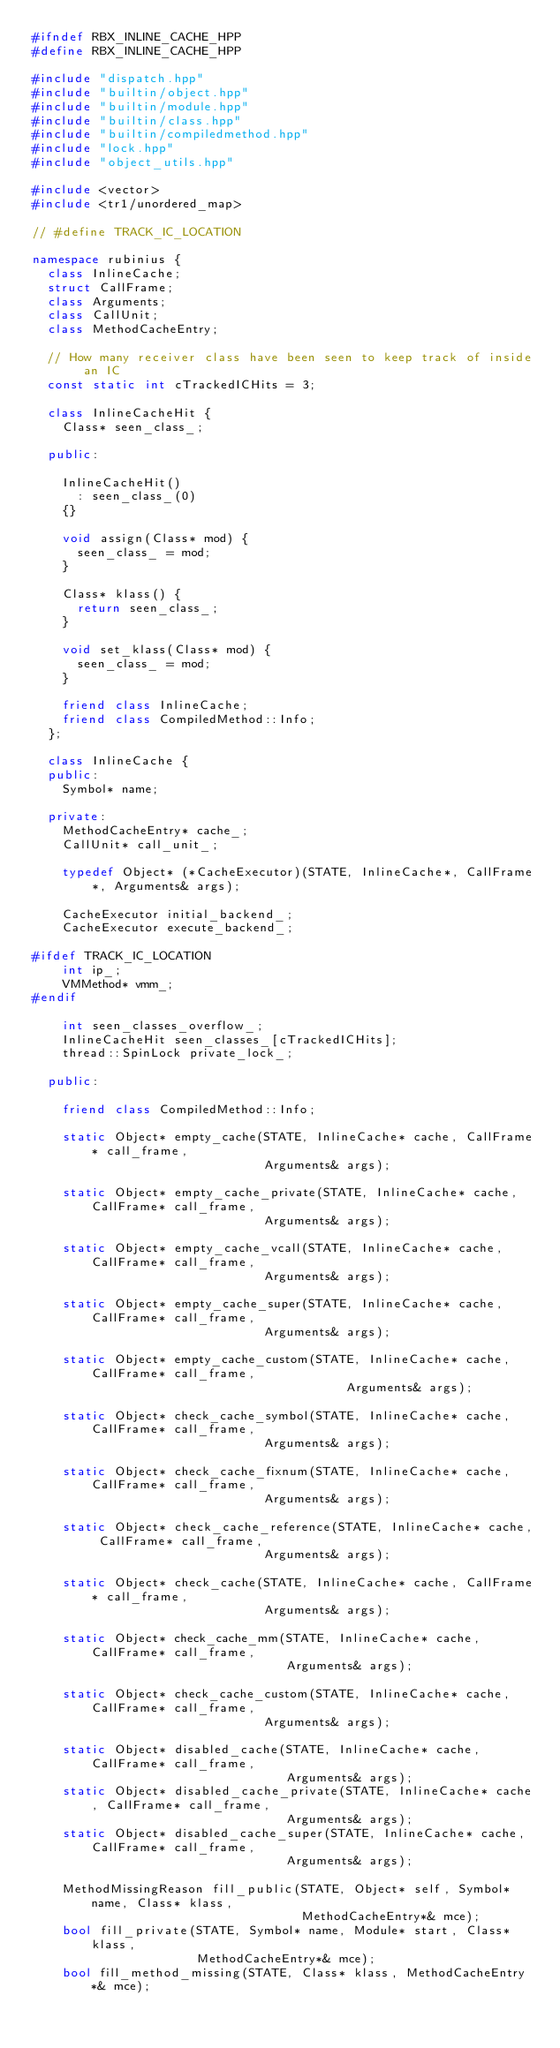Convert code to text. <code><loc_0><loc_0><loc_500><loc_500><_C++_>#ifndef RBX_INLINE_CACHE_HPP
#define RBX_INLINE_CACHE_HPP

#include "dispatch.hpp"
#include "builtin/object.hpp"
#include "builtin/module.hpp"
#include "builtin/class.hpp"
#include "builtin/compiledmethod.hpp"
#include "lock.hpp"
#include "object_utils.hpp"

#include <vector>
#include <tr1/unordered_map>

// #define TRACK_IC_LOCATION

namespace rubinius {
  class InlineCache;
  struct CallFrame;
  class Arguments;
  class CallUnit;
  class MethodCacheEntry;

  // How many receiver class have been seen to keep track of inside an IC
  const static int cTrackedICHits = 3;

  class InlineCacheHit {
    Class* seen_class_;

  public:

    InlineCacheHit()
      : seen_class_(0)
    {}

    void assign(Class* mod) {
      seen_class_ = mod;
    }

    Class* klass() {
      return seen_class_;
    }

    void set_klass(Class* mod) {
      seen_class_ = mod;
    }

    friend class InlineCache;
    friend class CompiledMethod::Info;
  };

  class InlineCache {
  public:
    Symbol* name;

  private:
    MethodCacheEntry* cache_;
    CallUnit* call_unit_;

    typedef Object* (*CacheExecutor)(STATE, InlineCache*, CallFrame*, Arguments& args);

    CacheExecutor initial_backend_;
    CacheExecutor execute_backend_;

#ifdef TRACK_IC_LOCATION
    int ip_;
    VMMethod* vmm_;
#endif

    int seen_classes_overflow_;
    InlineCacheHit seen_classes_[cTrackedICHits];
    thread::SpinLock private_lock_;

  public:

    friend class CompiledMethod::Info;

    static Object* empty_cache(STATE, InlineCache* cache, CallFrame* call_frame,
                               Arguments& args);

    static Object* empty_cache_private(STATE, InlineCache* cache, CallFrame* call_frame,
                               Arguments& args);

    static Object* empty_cache_vcall(STATE, InlineCache* cache, CallFrame* call_frame,
                               Arguments& args);

    static Object* empty_cache_super(STATE, InlineCache* cache, CallFrame* call_frame,
                               Arguments& args);

    static Object* empty_cache_custom(STATE, InlineCache* cache, CallFrame* call_frame,
                                          Arguments& args);

    static Object* check_cache_symbol(STATE, InlineCache* cache, CallFrame* call_frame,
                               Arguments& args);

    static Object* check_cache_fixnum(STATE, InlineCache* cache, CallFrame* call_frame,
                               Arguments& args);

    static Object* check_cache_reference(STATE, InlineCache* cache, CallFrame* call_frame,
                               Arguments& args);

    static Object* check_cache(STATE, InlineCache* cache, CallFrame* call_frame,
                               Arguments& args);

    static Object* check_cache_mm(STATE, InlineCache* cache, CallFrame* call_frame,
                                  Arguments& args);

    static Object* check_cache_custom(STATE, InlineCache* cache, CallFrame* call_frame,
                               Arguments& args);

    static Object* disabled_cache(STATE, InlineCache* cache, CallFrame* call_frame,
                                  Arguments& args);
    static Object* disabled_cache_private(STATE, InlineCache* cache, CallFrame* call_frame,
                                  Arguments& args);
    static Object* disabled_cache_super(STATE, InlineCache* cache, CallFrame* call_frame,
                                  Arguments& args);

    MethodMissingReason fill_public(STATE, Object* self, Symbol* name, Class* klass,
                                    MethodCacheEntry*& mce);
    bool fill_private(STATE, Symbol* name, Module* start, Class* klass,
                      MethodCacheEntry*& mce);
    bool fill_method_missing(STATE, Class* klass, MethodCacheEntry*& mce);
</code> 